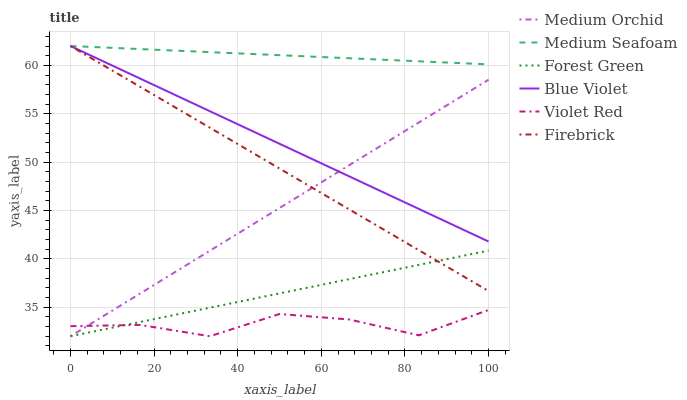Does Violet Red have the minimum area under the curve?
Answer yes or no. Yes. Does Medium Seafoam have the maximum area under the curve?
Answer yes or no. Yes. Does Firebrick have the minimum area under the curve?
Answer yes or no. No. Does Firebrick have the maximum area under the curve?
Answer yes or no. No. Is Blue Violet the smoothest?
Answer yes or no. Yes. Is Violet Red the roughest?
Answer yes or no. Yes. Is Firebrick the smoothest?
Answer yes or no. No. Is Firebrick the roughest?
Answer yes or no. No. Does Firebrick have the lowest value?
Answer yes or no. No. Does Blue Violet have the highest value?
Answer yes or no. Yes. Does Medium Orchid have the highest value?
Answer yes or no. No. Is Forest Green less than Medium Seafoam?
Answer yes or no. Yes. Is Medium Seafoam greater than Medium Orchid?
Answer yes or no. Yes. Does Blue Violet intersect Medium Orchid?
Answer yes or no. Yes. Is Blue Violet less than Medium Orchid?
Answer yes or no. No. Is Blue Violet greater than Medium Orchid?
Answer yes or no. No. Does Forest Green intersect Medium Seafoam?
Answer yes or no. No. 